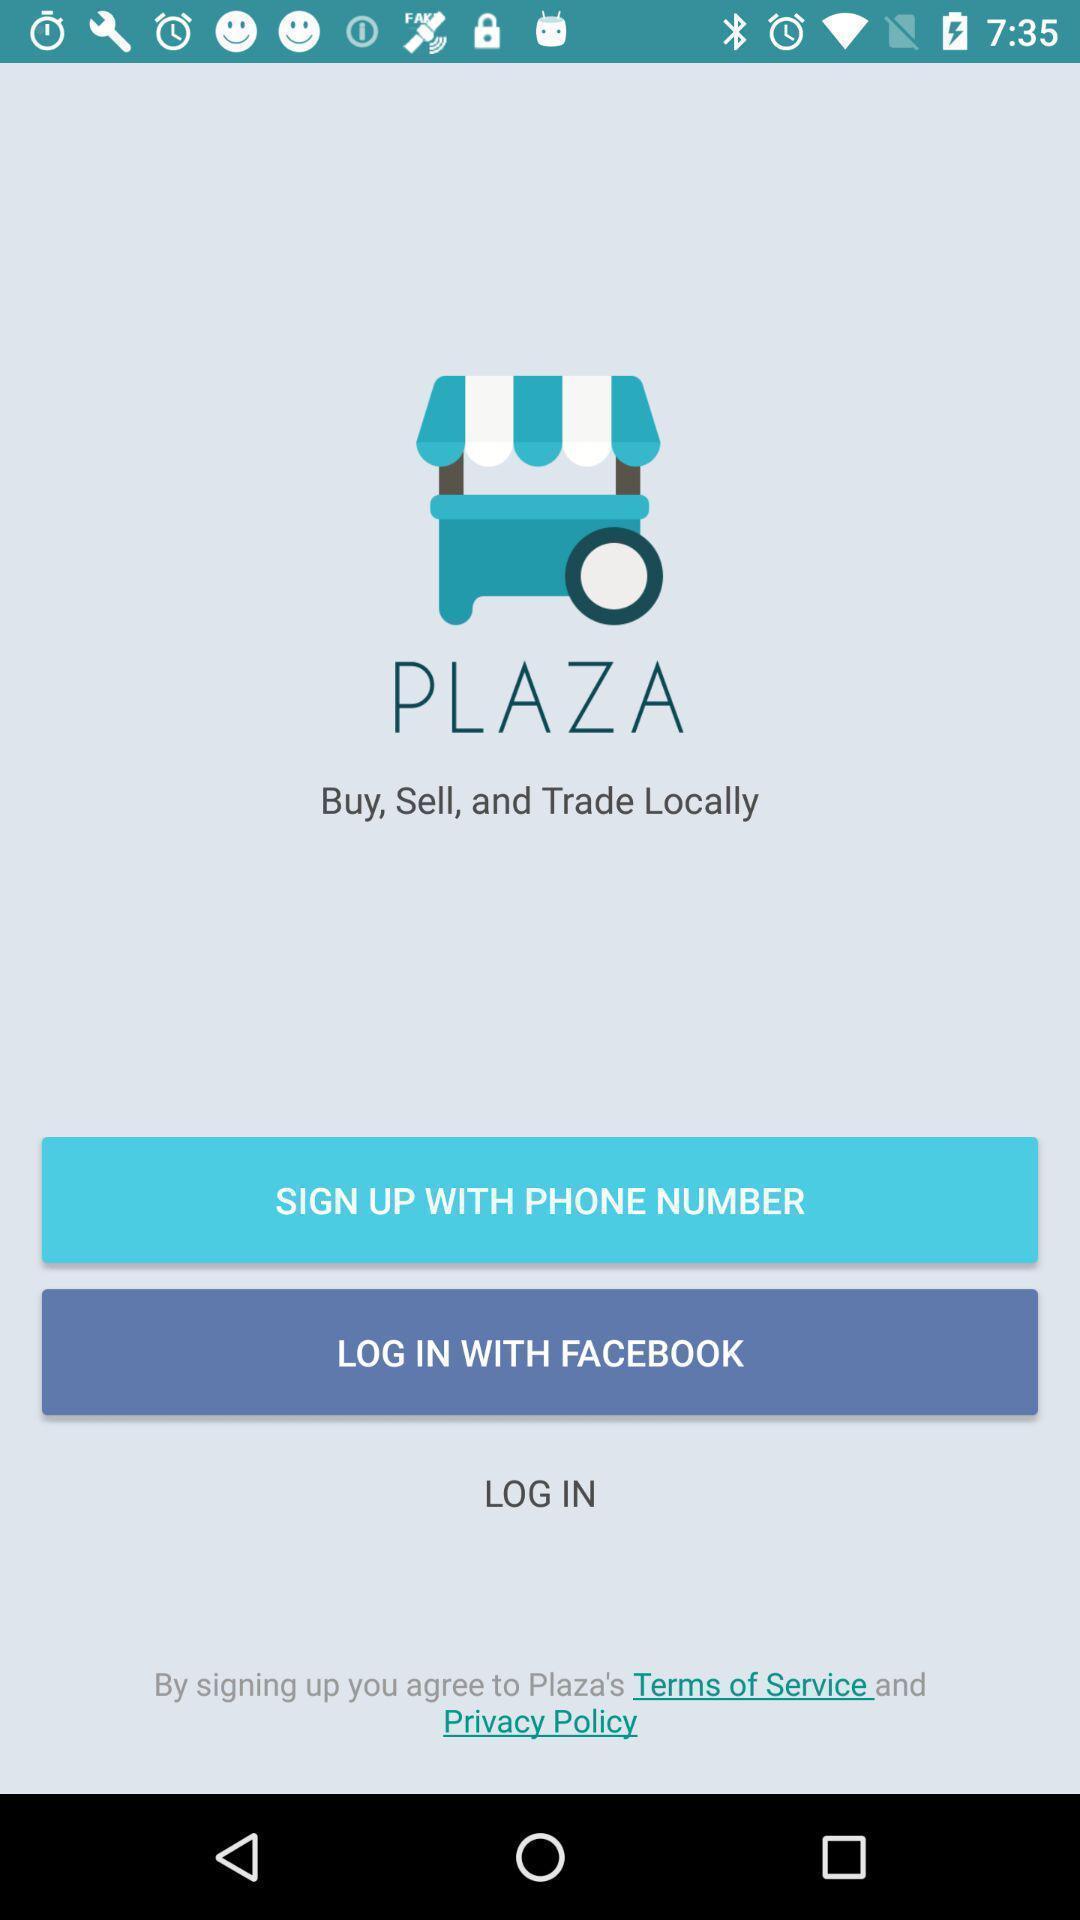Describe the content in this image. Welcome page. 